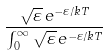<formula> <loc_0><loc_0><loc_500><loc_500>\frac { { \sqrt { \varepsilon } } \, e ^ { - \varepsilon / k T } } { \int _ { 0 } ^ { \infty } { \sqrt { \varepsilon } } \, e ^ { - \varepsilon / k T } }</formula> 